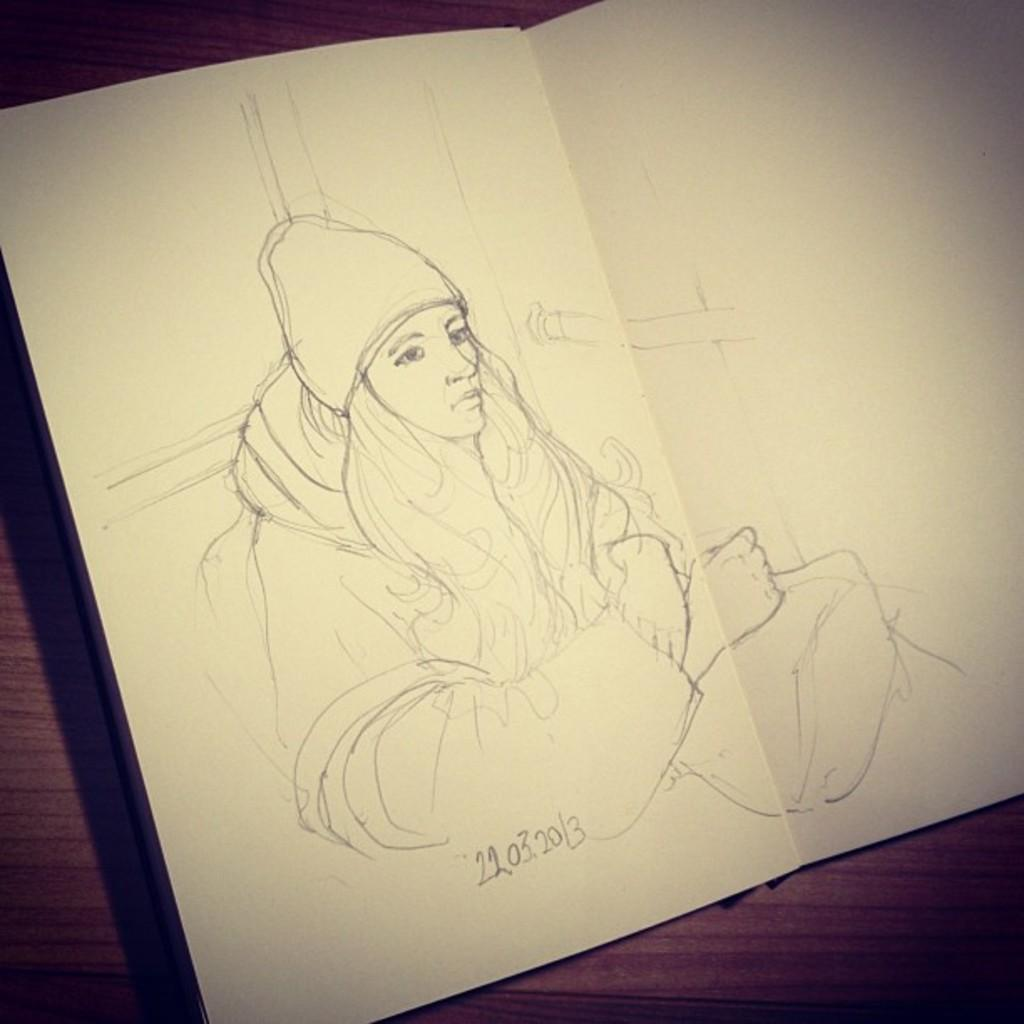What type of art is featured in the image? There is pencil art in the image. Can you describe the subject of the art? The art depicts a woman in a hoodie. Where is the art located in the image? The art is on a table. What type of cloud can be seen in the background of the pencil art? There is no cloud visible in the image, as it features pencil art of a woman in a hoodie on a table. 